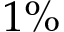Convert formula to latex. <formula><loc_0><loc_0><loc_500><loc_500>1 \%</formula> 